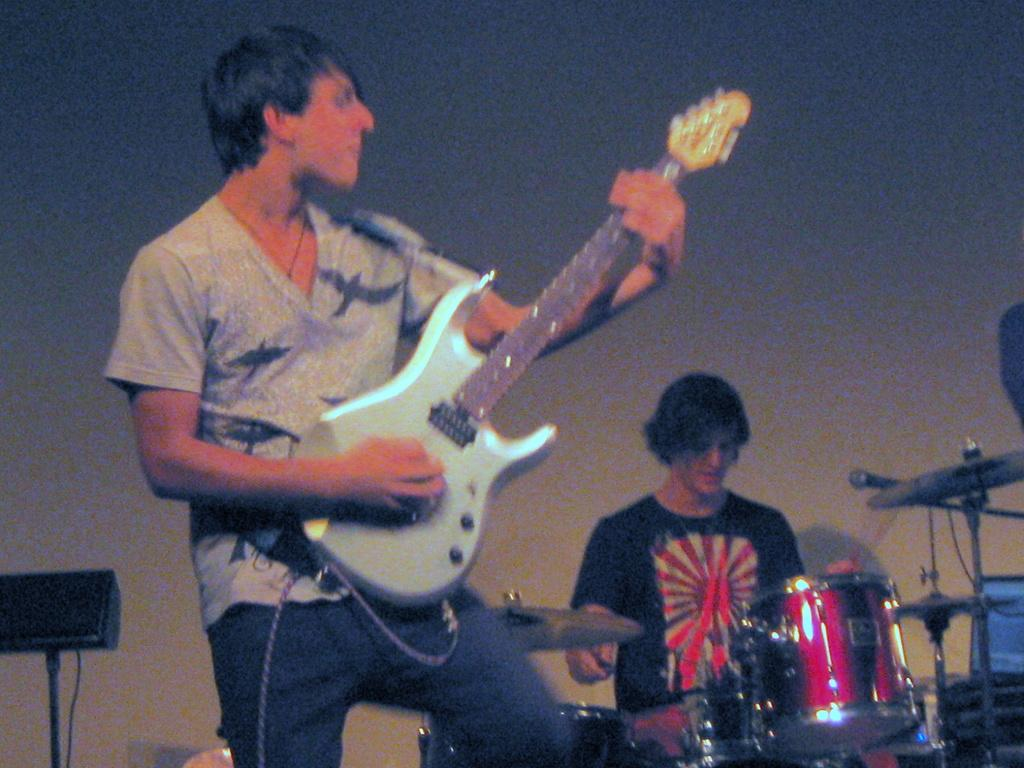What is the man in the foreground of the image doing? The man in the foreground is standing and playing a guitar. What is the other man in the image doing? The other man is sitting and playing a musical instrument. What can be seen in the background of the image? There is a wall in the background of the image. What type of cake is being served on the bridge in the image? There is no bridge or cake present in the image; it features two men playing musical instruments with a wall in the background. 